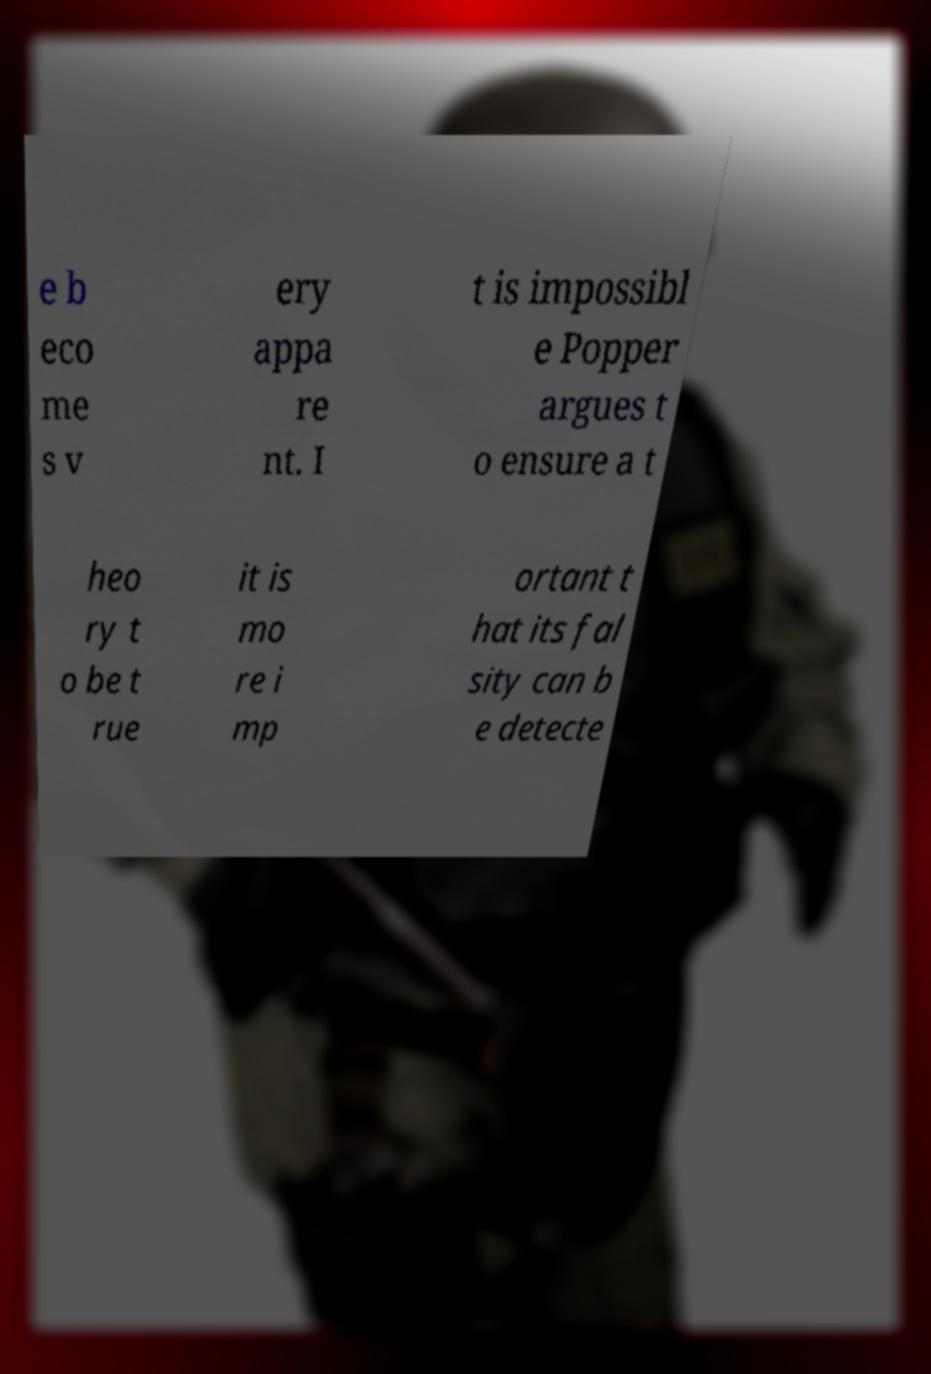Please read and relay the text visible in this image. What does it say? e b eco me s v ery appa re nt. I t is impossibl e Popper argues t o ensure a t heo ry t o be t rue it is mo re i mp ortant t hat its fal sity can b e detecte 